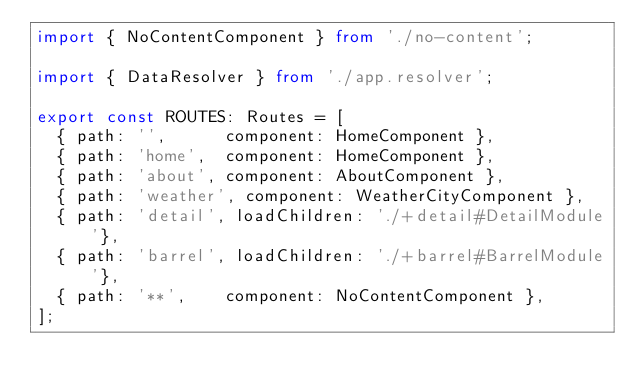Convert code to text. <code><loc_0><loc_0><loc_500><loc_500><_TypeScript_>import { NoContentComponent } from './no-content';

import { DataResolver } from './app.resolver';

export const ROUTES: Routes = [
  { path: '',      component: HomeComponent },
  { path: 'home',  component: HomeComponent },
  { path: 'about', component: AboutComponent },
  { path: 'weather', component: WeatherCityComponent },
  { path: 'detail', loadChildren: './+detail#DetailModule'},
  { path: 'barrel', loadChildren: './+barrel#BarrelModule'},
  { path: '**',    component: NoContentComponent },
];
</code> 